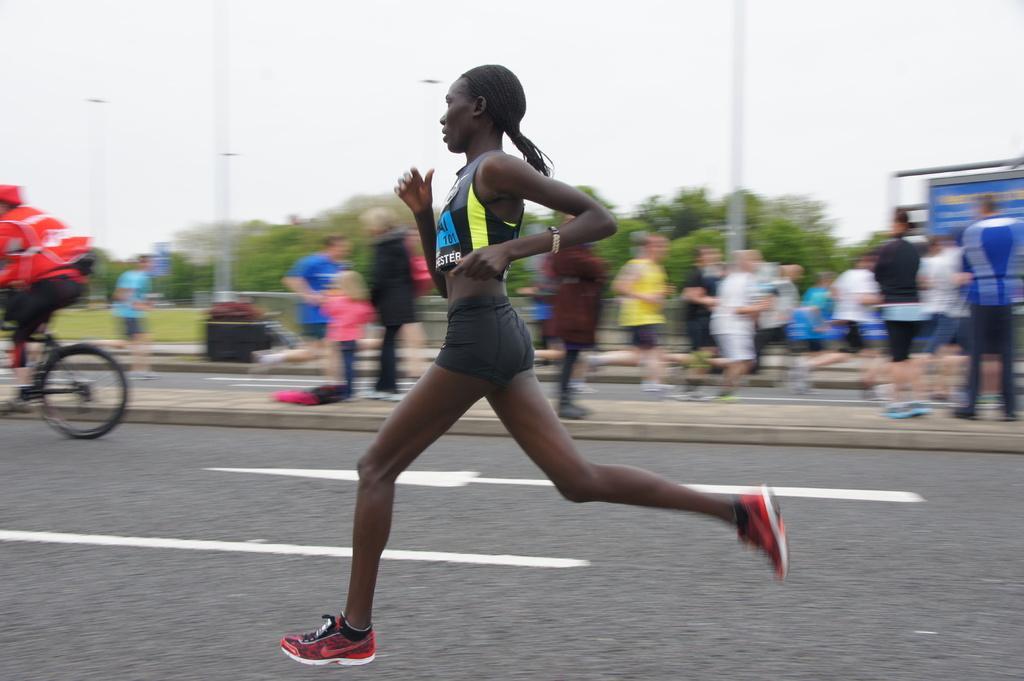Could you give a brief overview of what you see in this image? As we can see in the image there are few people here and there, trees, sky and banner. On the left side there is a man wearing red color jacket and riding bicycle. 